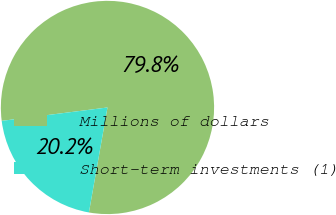Convert chart. <chart><loc_0><loc_0><loc_500><loc_500><pie_chart><fcel>Millions of dollars<fcel>Short-term investments (1)<nl><fcel>79.79%<fcel>20.21%<nl></chart> 